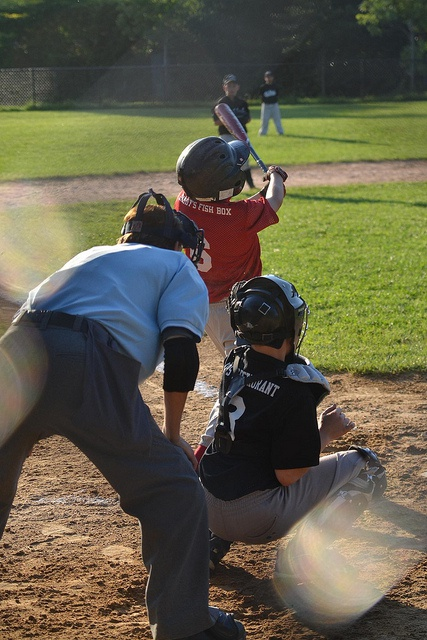Describe the objects in this image and their specific colors. I can see people in darkgreen, black, gray, and blue tones, people in darkgreen, black, gray, darkgray, and maroon tones, people in darkgreen, maroon, black, and gray tones, people in darkgreen, black, and gray tones, and people in darkgreen, gray, black, and darkgray tones in this image. 